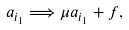<formula> <loc_0><loc_0><loc_500><loc_500>a _ { i _ { 1 } } \Longrightarrow \mu a _ { i _ { 1 } } + f ,</formula> 